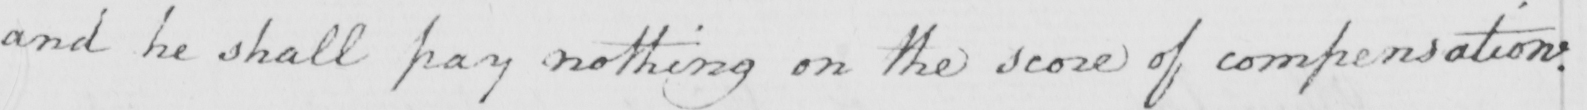Transcribe the text shown in this historical manuscript line. and he shall pay nothing on the score of compensation . 